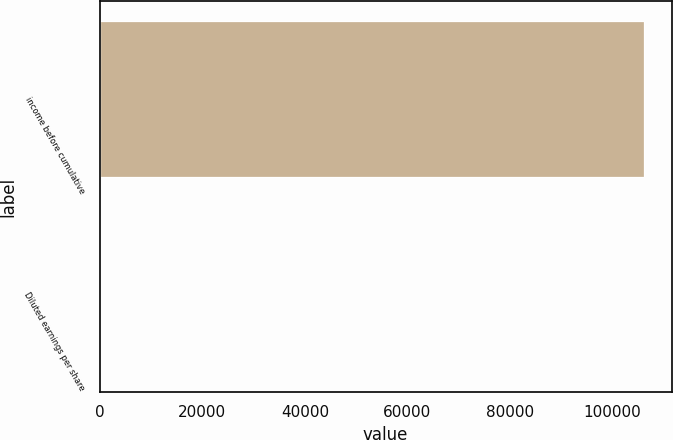Convert chart to OTSL. <chart><loc_0><loc_0><loc_500><loc_500><bar_chart><fcel>income before cumulative<fcel>Diluted earnings per share<nl><fcel>106184<fcel>1.47<nl></chart> 